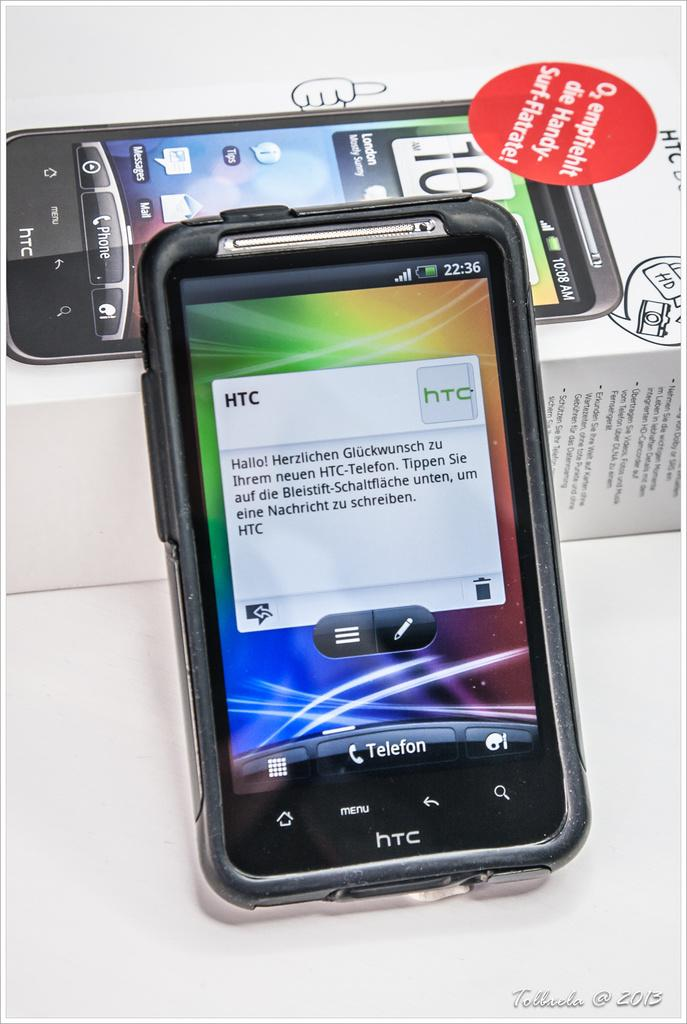<image>
Share a concise interpretation of the image provided. An HTC phone's screen displays a message that begins "Hallo!" 